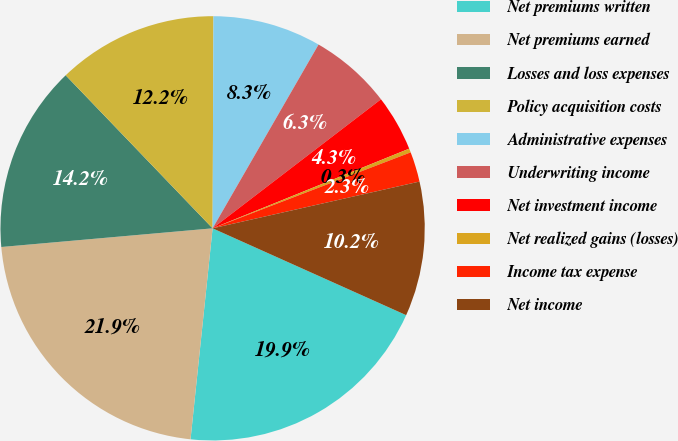Convert chart. <chart><loc_0><loc_0><loc_500><loc_500><pie_chart><fcel>Net premiums written<fcel>Net premiums earned<fcel>Losses and loss expenses<fcel>Policy acquisition costs<fcel>Administrative expenses<fcel>Underwriting income<fcel>Net investment income<fcel>Net realized gains (losses)<fcel>Income tax expense<fcel>Net income<nl><fcel>19.95%<fcel>21.94%<fcel>14.23%<fcel>12.24%<fcel>8.26%<fcel>6.27%<fcel>4.28%<fcel>0.3%<fcel>2.29%<fcel>10.25%<nl></chart> 